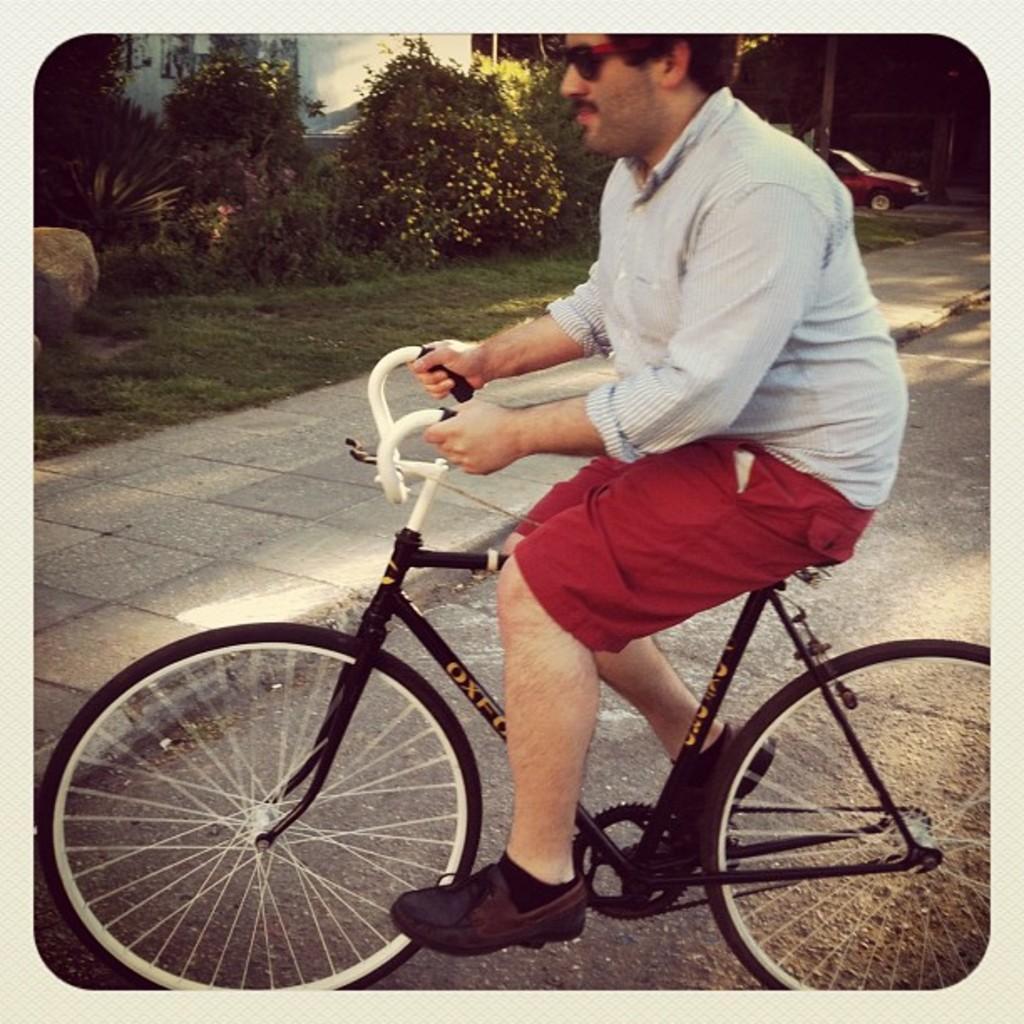Can you describe this image briefly? In this picture we can see man sitting on bicycle and riding it on road and aside to that there is a foot path, grass, tree and in background we can see a car. 